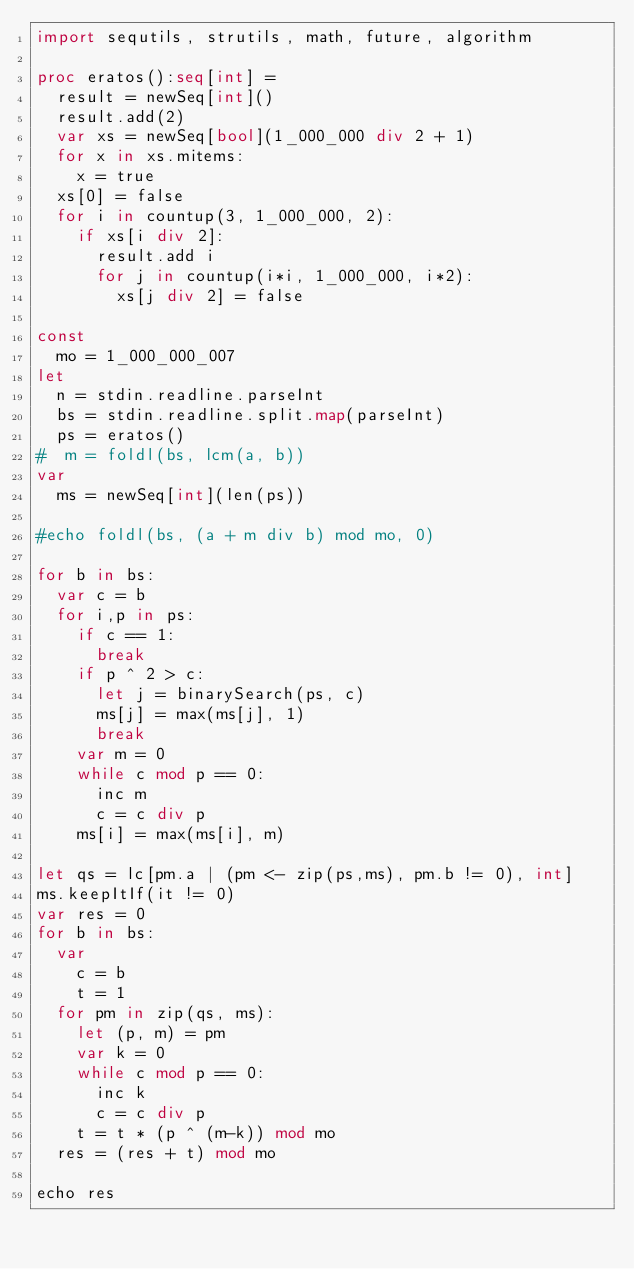<code> <loc_0><loc_0><loc_500><loc_500><_Nim_>import sequtils, strutils, math, future, algorithm
 
proc eratos():seq[int] =
  result = newSeq[int]()
  result.add(2)
  var xs = newSeq[bool](1_000_000 div 2 + 1)
  for x in xs.mitems:
    x = true
  xs[0] = false
  for i in countup(3, 1_000_000, 2):
    if xs[i div 2]:
      result.add i
      for j in countup(i*i, 1_000_000, i*2):
        xs[j div 2] = false
 
const
  mo = 1_000_000_007
let
  n = stdin.readline.parseInt
  bs = stdin.readline.split.map(parseInt)
  ps = eratos()
#  m = foldl(bs, lcm(a, b))
var
  ms = newSeq[int](len(ps))
 
#echo foldl(bs, (a + m div b) mod mo, 0)
 
for b in bs:
  var c = b
  for i,p in ps:
    if c == 1:
      break
    if p ^ 2 > c:
      let j = binarySearch(ps, c)
      ms[j] = max(ms[j], 1)
      break
    var m = 0
    while c mod p == 0:
      inc m
      c = c div p
    ms[i] = max(ms[i], m)
 
let qs = lc[pm.a | (pm <- zip(ps,ms), pm.b != 0), int]
ms.keepItIf(it != 0)
var res = 0
for b in bs:
  var
    c = b
    t = 1
  for pm in zip(qs, ms):
    let (p, m) = pm
    var k = 0
    while c mod p == 0:
      inc k
      c = c div p
    t = t * (p ^ (m-k)) mod mo
  res = (res + t) mod mo
 
echo res</code> 